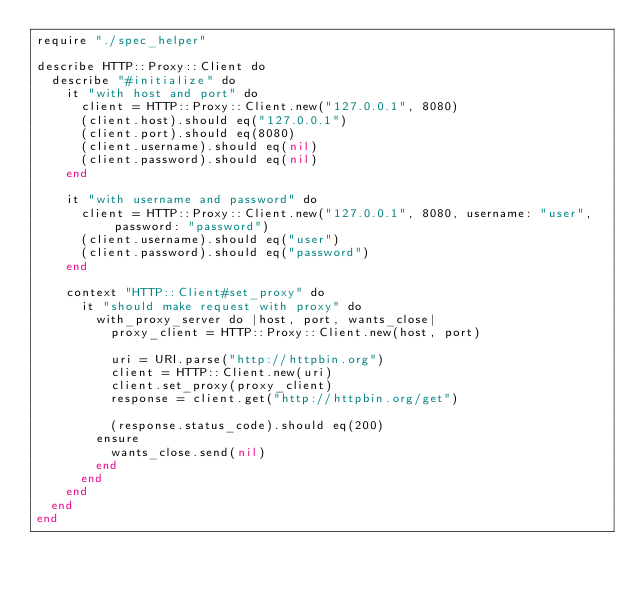Convert code to text. <code><loc_0><loc_0><loc_500><loc_500><_Crystal_>require "./spec_helper"

describe HTTP::Proxy::Client do
  describe "#initialize" do
    it "with host and port" do
      client = HTTP::Proxy::Client.new("127.0.0.1", 8080)
      (client.host).should eq("127.0.0.1")
      (client.port).should eq(8080)
      (client.username).should eq(nil)
      (client.password).should eq(nil)
    end

    it "with username and password" do
      client = HTTP::Proxy::Client.new("127.0.0.1", 8080, username: "user", password: "password")
      (client.username).should eq("user")
      (client.password).should eq("password")
    end

    context "HTTP::Client#set_proxy" do
      it "should make request with proxy" do
        with_proxy_server do |host, port, wants_close|
          proxy_client = HTTP::Proxy::Client.new(host, port)

          uri = URI.parse("http://httpbin.org")
          client = HTTP::Client.new(uri)
          client.set_proxy(proxy_client)
          response = client.get("http://httpbin.org/get")

          (response.status_code).should eq(200)
        ensure
          wants_close.send(nil)
        end
      end
    end
  end
end
</code> 